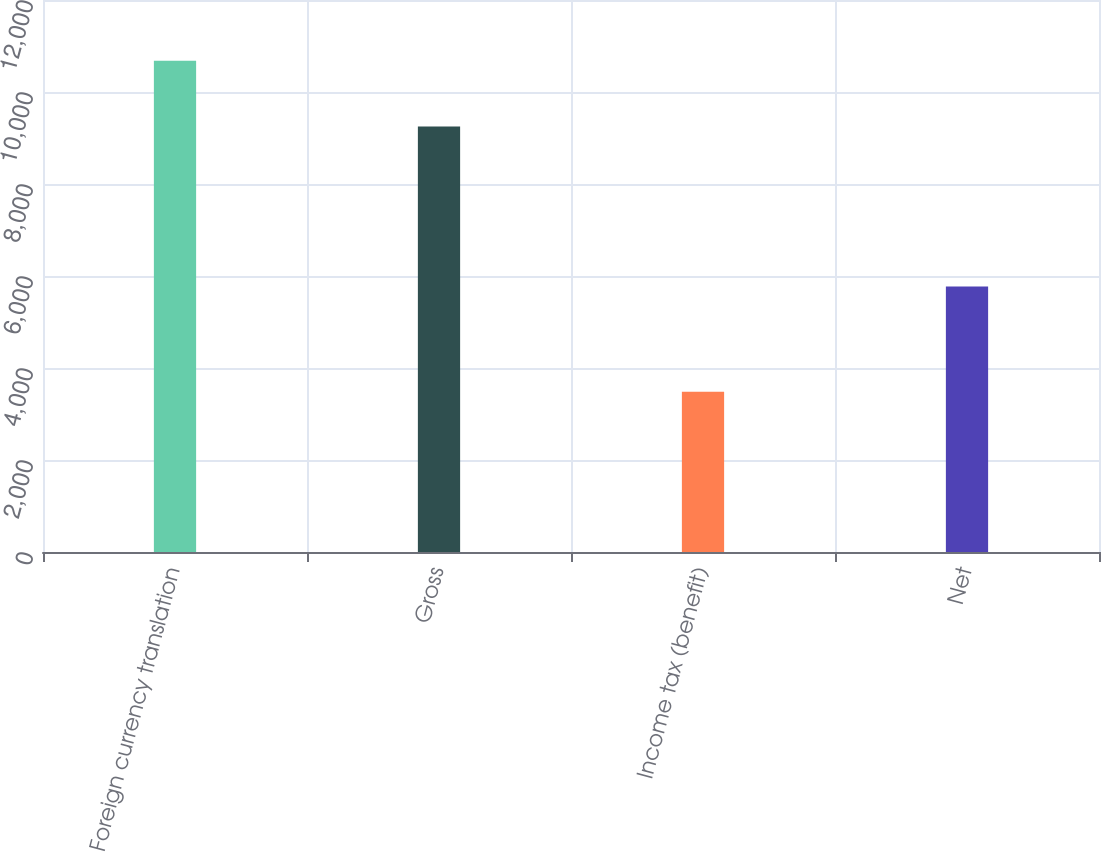Convert chart. <chart><loc_0><loc_0><loc_500><loc_500><bar_chart><fcel>Foreign currency translation<fcel>Gross<fcel>Income tax (benefit)<fcel>Net<nl><fcel>10677<fcel>9252<fcel>3482<fcel>5770<nl></chart> 